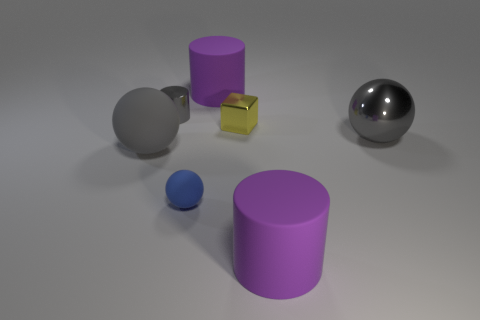Add 2 gray shiny objects. How many objects exist? 9 Subtract all cylinders. How many objects are left? 4 Subtract 1 gray cylinders. How many objects are left? 6 Subtract all yellow rubber cubes. Subtract all large purple cylinders. How many objects are left? 5 Add 7 big balls. How many big balls are left? 9 Add 3 purple metal cylinders. How many purple metal cylinders exist? 3 